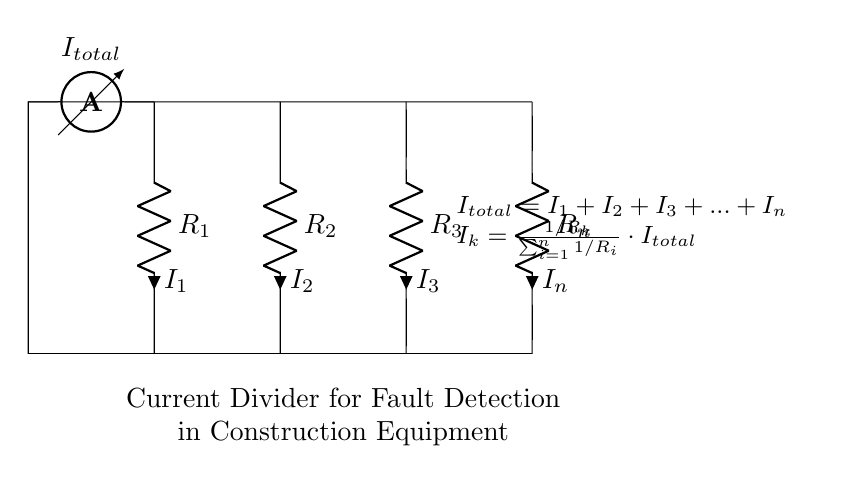What is the total current in the circuit? The total current is represented as I_total in the diagram, which is the sum of all individual currents, I_1, I_2, I_3, ..., I_n.
Answer: I_total What does the ammeter measure in this circuit? The ammeter measures the total current I_total flowing through the circuit, indicating the overall current entering the resistive branches.
Answer: Total current How many resistors are present in this current divider? The diagram depicts n resistors, as indicated by R_1, R_2, R_3, and R_n. The question specifies how many there are, which we refer to as n.
Answer: n What is the relationship between I_k and R_k? The relationship is defined by the current divider rule, which states that I_k is inversely proportional to R_k among all resistors. Therefore, the higher the resistance R_k, the lower the current I_k flowing through it relative to the total current.
Answer: Inversely proportional If R_2 is doubled, what happens to I_2? By doubling R_2, its effect on current I_2 will decrease, since increasing resistance leads to a smaller current according to the current divider rule. Thus, if R_2 becomes larger, I_2 will become smaller, maintaining the balance of total current.
Answer: I_2 decreases What is the formula representing the current through resistor R_k? The formula is given as I_k = (1/R_k) / (sum(1/R_i for i from 1 to n)) * I_total, clearly specifying how the current through each resistor is calculated based on the total current and individual resistances.
Answer: I_k = (1/R_k) / (sum(1/R_i for i from 1 to n)) * I_total 